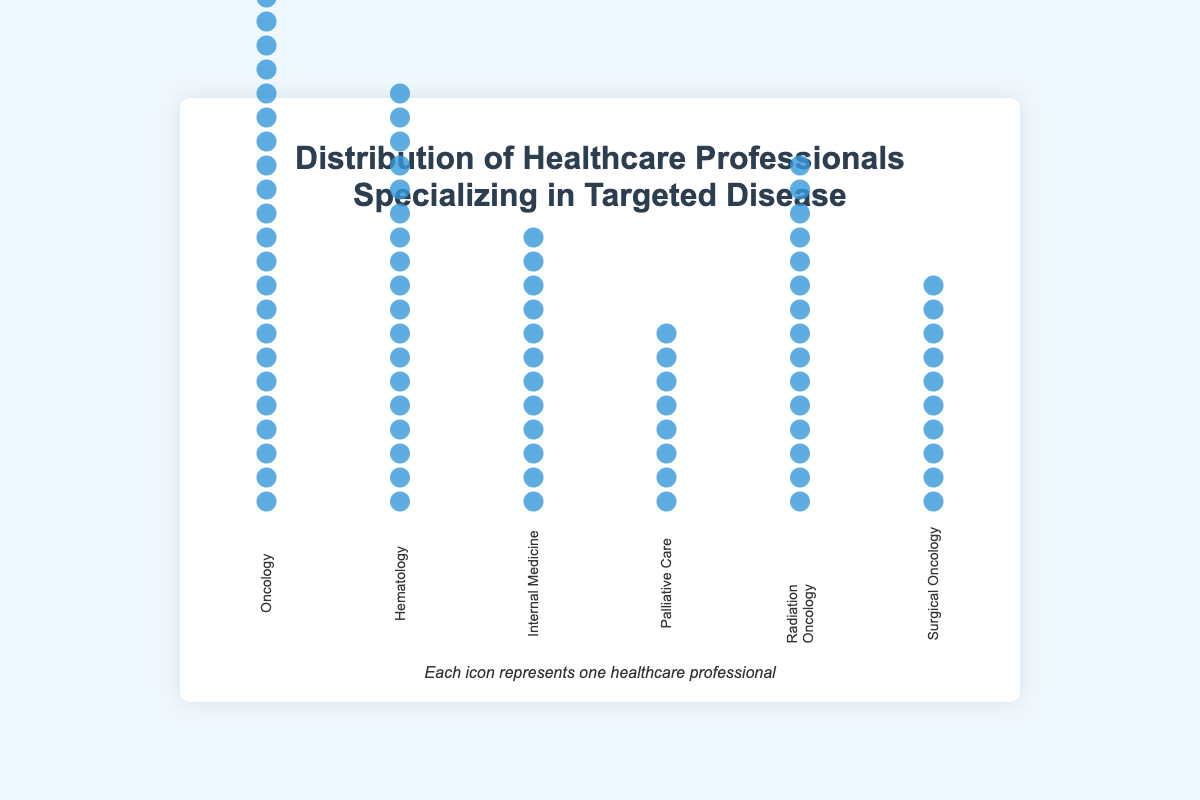How many healthcare professionals specializing in the targeted disease are in the Oncology department? Count the icons in the section labeled 'Oncology'. Each icon represents one healthcare professional.
Answer: 25 Which department has the fewest healthcare professionals specializing in the targeted disease? Compare the icon counts in each department. The section with the least number of icons represents the department with the fewest healthcare professionals.
Answer: Palliative Care What is the total number of healthcare professionals across all departments? Add the number of specialists from all departments: 25 (Oncology) + 18 (Hematology) + 12 (Internal Medicine) + 8 (Palliative Care) + 15 (Radiation Oncology) + 10 (Surgical Oncology).
Answer: 88 Which department has more specialists, Hematology or Radiation Oncology? Compare the number of icons in the Hematology section with the number of icons in the Radiation Oncology section.
Answer: Hematology How many more specialists are there in Oncology compared to Palliative Care? Subtract the number of Palliative Care specialists from the number of Oncology specialists: 25 - 8.
Answer: 17 What is the average number of healthcare professionals per department? Divide the total number of specialists by the number of departments: 88 / 6.
Answer: 14.67 Which departments have more than 10 specialists? Identify the sections where the count of icons is greater than 10: Oncology, Hematology, and Radiation Oncology.
Answer: Oncology, Hematology, Radiation Oncology Is the number of specialists in Surgical Oncology greater than the number in Internal Medicine? Compare the number of icons in the Surgical Oncology section with the Internal Medicine section: 10 vs. 12.
Answer: No Between Radiation Oncology and Surgical Oncology, which department has fewer healthcare professionals? Compare the number of icons in Radiation Oncology with the number in Surgical Oncology: 15 vs. 10.
Answer: Surgical Oncology What is the difference in the number of specialists between Hematology and Internal Medicine? Subtract the number of Internal Medicine specialists from the number of Hematology specialists: 18 - 12.
Answer: 6 